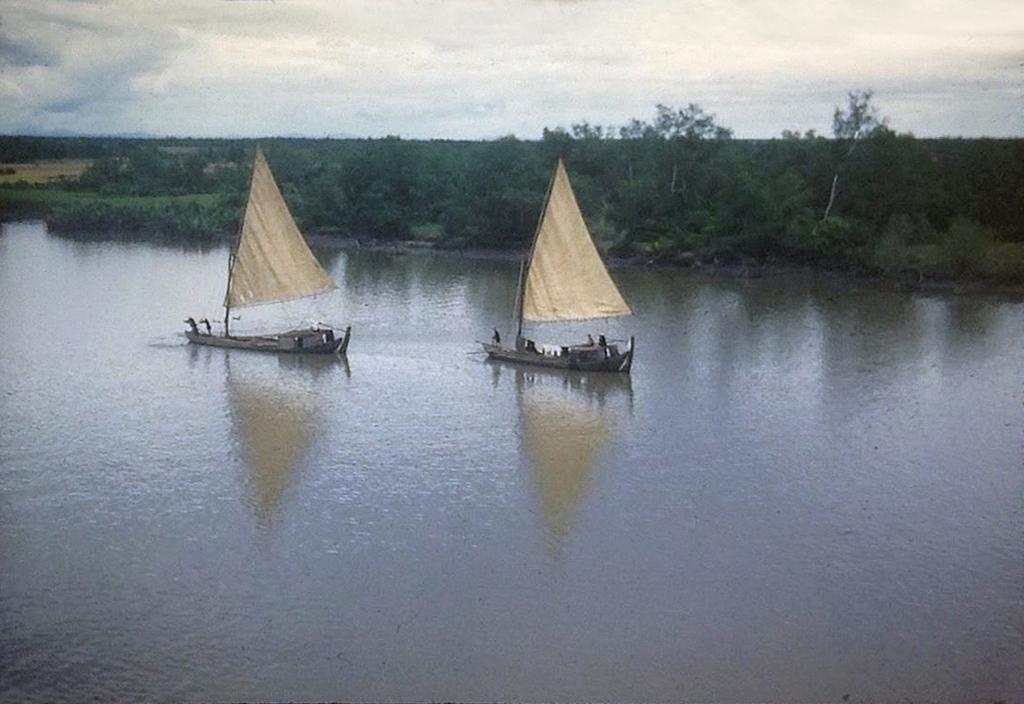How many boats can be seen in the image? There are two boats in the image. Where are the boats located? The boats are on the water. What can be seen in the background of the image? There are trees and the sky visible in the background of the image. What type of magic is being performed by the boats in the image? There is no magic being performed by the boats in the image; they are simply floating on the water. 